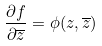Convert formula to latex. <formula><loc_0><loc_0><loc_500><loc_500>\frac { \partial f } { \partial \overline { z } } = \phi ( z , \overline { z } )</formula> 